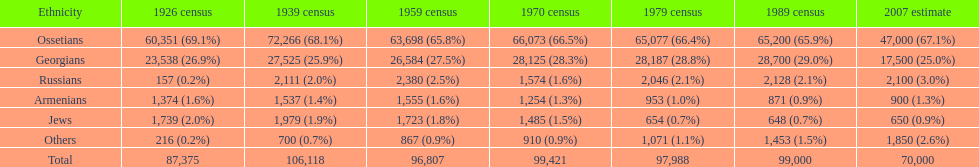Which population had the most people in 1926? Ossetians. 